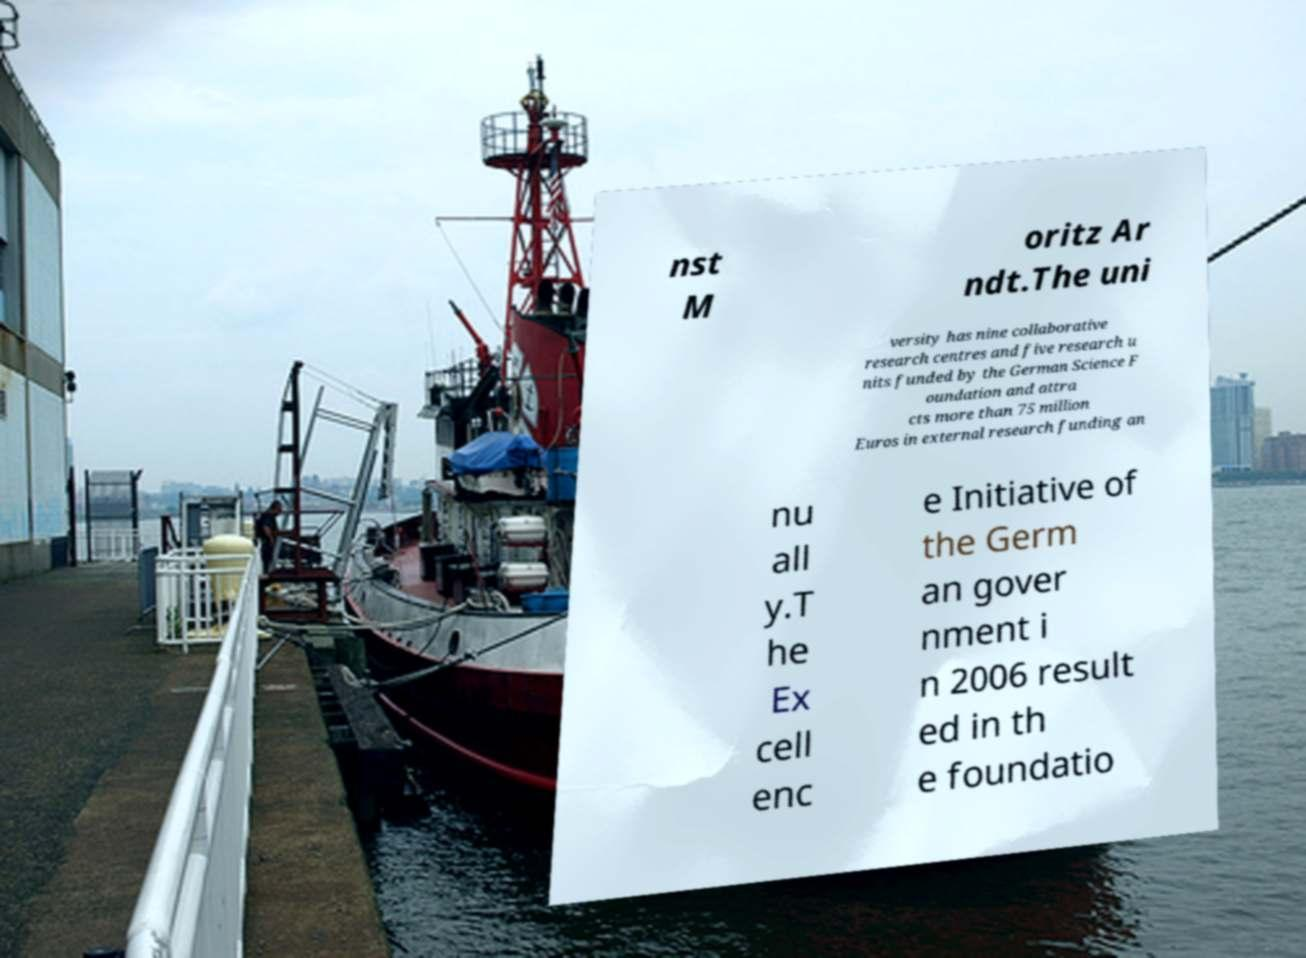There's text embedded in this image that I need extracted. Can you transcribe it verbatim? nst M oritz Ar ndt.The uni versity has nine collaborative research centres and five research u nits funded by the German Science F oundation and attra cts more than 75 million Euros in external research funding an nu all y.T he Ex cell enc e Initiative of the Germ an gover nment i n 2006 result ed in th e foundatio 